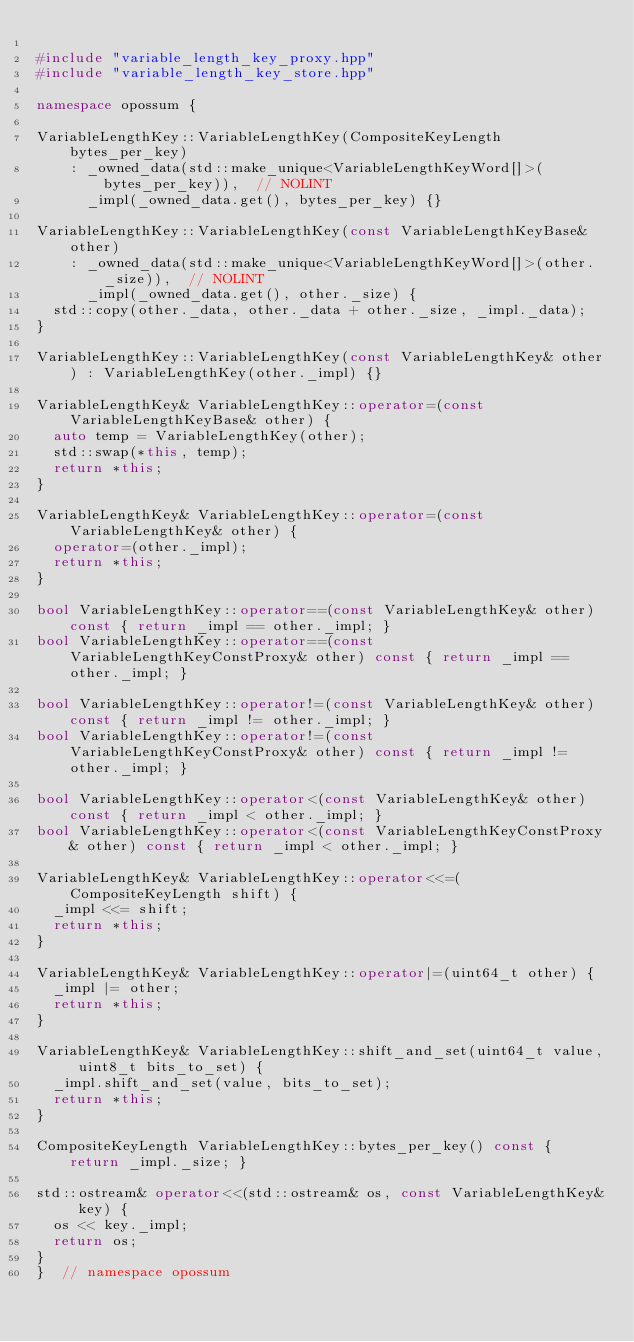<code> <loc_0><loc_0><loc_500><loc_500><_C++_>
#include "variable_length_key_proxy.hpp"
#include "variable_length_key_store.hpp"

namespace opossum {

VariableLengthKey::VariableLengthKey(CompositeKeyLength bytes_per_key)
    : _owned_data(std::make_unique<VariableLengthKeyWord[]>(bytes_per_key)),  // NOLINT
      _impl(_owned_data.get(), bytes_per_key) {}

VariableLengthKey::VariableLengthKey(const VariableLengthKeyBase& other)
    : _owned_data(std::make_unique<VariableLengthKeyWord[]>(other._size)),  // NOLINT
      _impl(_owned_data.get(), other._size) {
  std::copy(other._data, other._data + other._size, _impl._data);
}

VariableLengthKey::VariableLengthKey(const VariableLengthKey& other) : VariableLengthKey(other._impl) {}

VariableLengthKey& VariableLengthKey::operator=(const VariableLengthKeyBase& other) {
  auto temp = VariableLengthKey(other);
  std::swap(*this, temp);
  return *this;
}

VariableLengthKey& VariableLengthKey::operator=(const VariableLengthKey& other) {
  operator=(other._impl);
  return *this;
}

bool VariableLengthKey::operator==(const VariableLengthKey& other) const { return _impl == other._impl; }
bool VariableLengthKey::operator==(const VariableLengthKeyConstProxy& other) const { return _impl == other._impl; }

bool VariableLengthKey::operator!=(const VariableLengthKey& other) const { return _impl != other._impl; }
bool VariableLengthKey::operator!=(const VariableLengthKeyConstProxy& other) const { return _impl != other._impl; }

bool VariableLengthKey::operator<(const VariableLengthKey& other) const { return _impl < other._impl; }
bool VariableLengthKey::operator<(const VariableLengthKeyConstProxy& other) const { return _impl < other._impl; }

VariableLengthKey& VariableLengthKey::operator<<=(CompositeKeyLength shift) {
  _impl <<= shift;
  return *this;
}

VariableLengthKey& VariableLengthKey::operator|=(uint64_t other) {
  _impl |= other;
  return *this;
}

VariableLengthKey& VariableLengthKey::shift_and_set(uint64_t value, uint8_t bits_to_set) {
  _impl.shift_and_set(value, bits_to_set);
  return *this;
}

CompositeKeyLength VariableLengthKey::bytes_per_key() const { return _impl._size; }

std::ostream& operator<<(std::ostream& os, const VariableLengthKey& key) {
  os << key._impl;
  return os;
}
}  // namespace opossum
</code> 